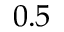Convert formula to latex. <formula><loc_0><loc_0><loc_500><loc_500>0 . 5</formula> 